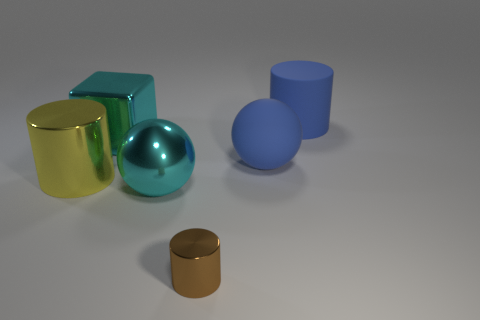Add 3 blue matte balls. How many objects exist? 9 Subtract all balls. How many objects are left? 4 Subtract 0 green cylinders. How many objects are left? 6 Subtract all cyan metal spheres. Subtract all brown cylinders. How many objects are left? 4 Add 6 big matte cylinders. How many big matte cylinders are left? 7 Add 4 large cubes. How many large cubes exist? 5 